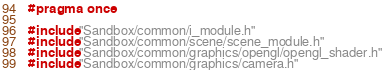<code> <loc_0><loc_0><loc_500><loc_500><_C_>#pragma once

#include "Sandbox/common/i_module.h"
#include "Sandbox/common/scene/scene_module.h"
#include "Sandbox/common/graphics/opengl/opengl_shader.h"
#include "Sandbox/common/graphics/camera.h"</code> 